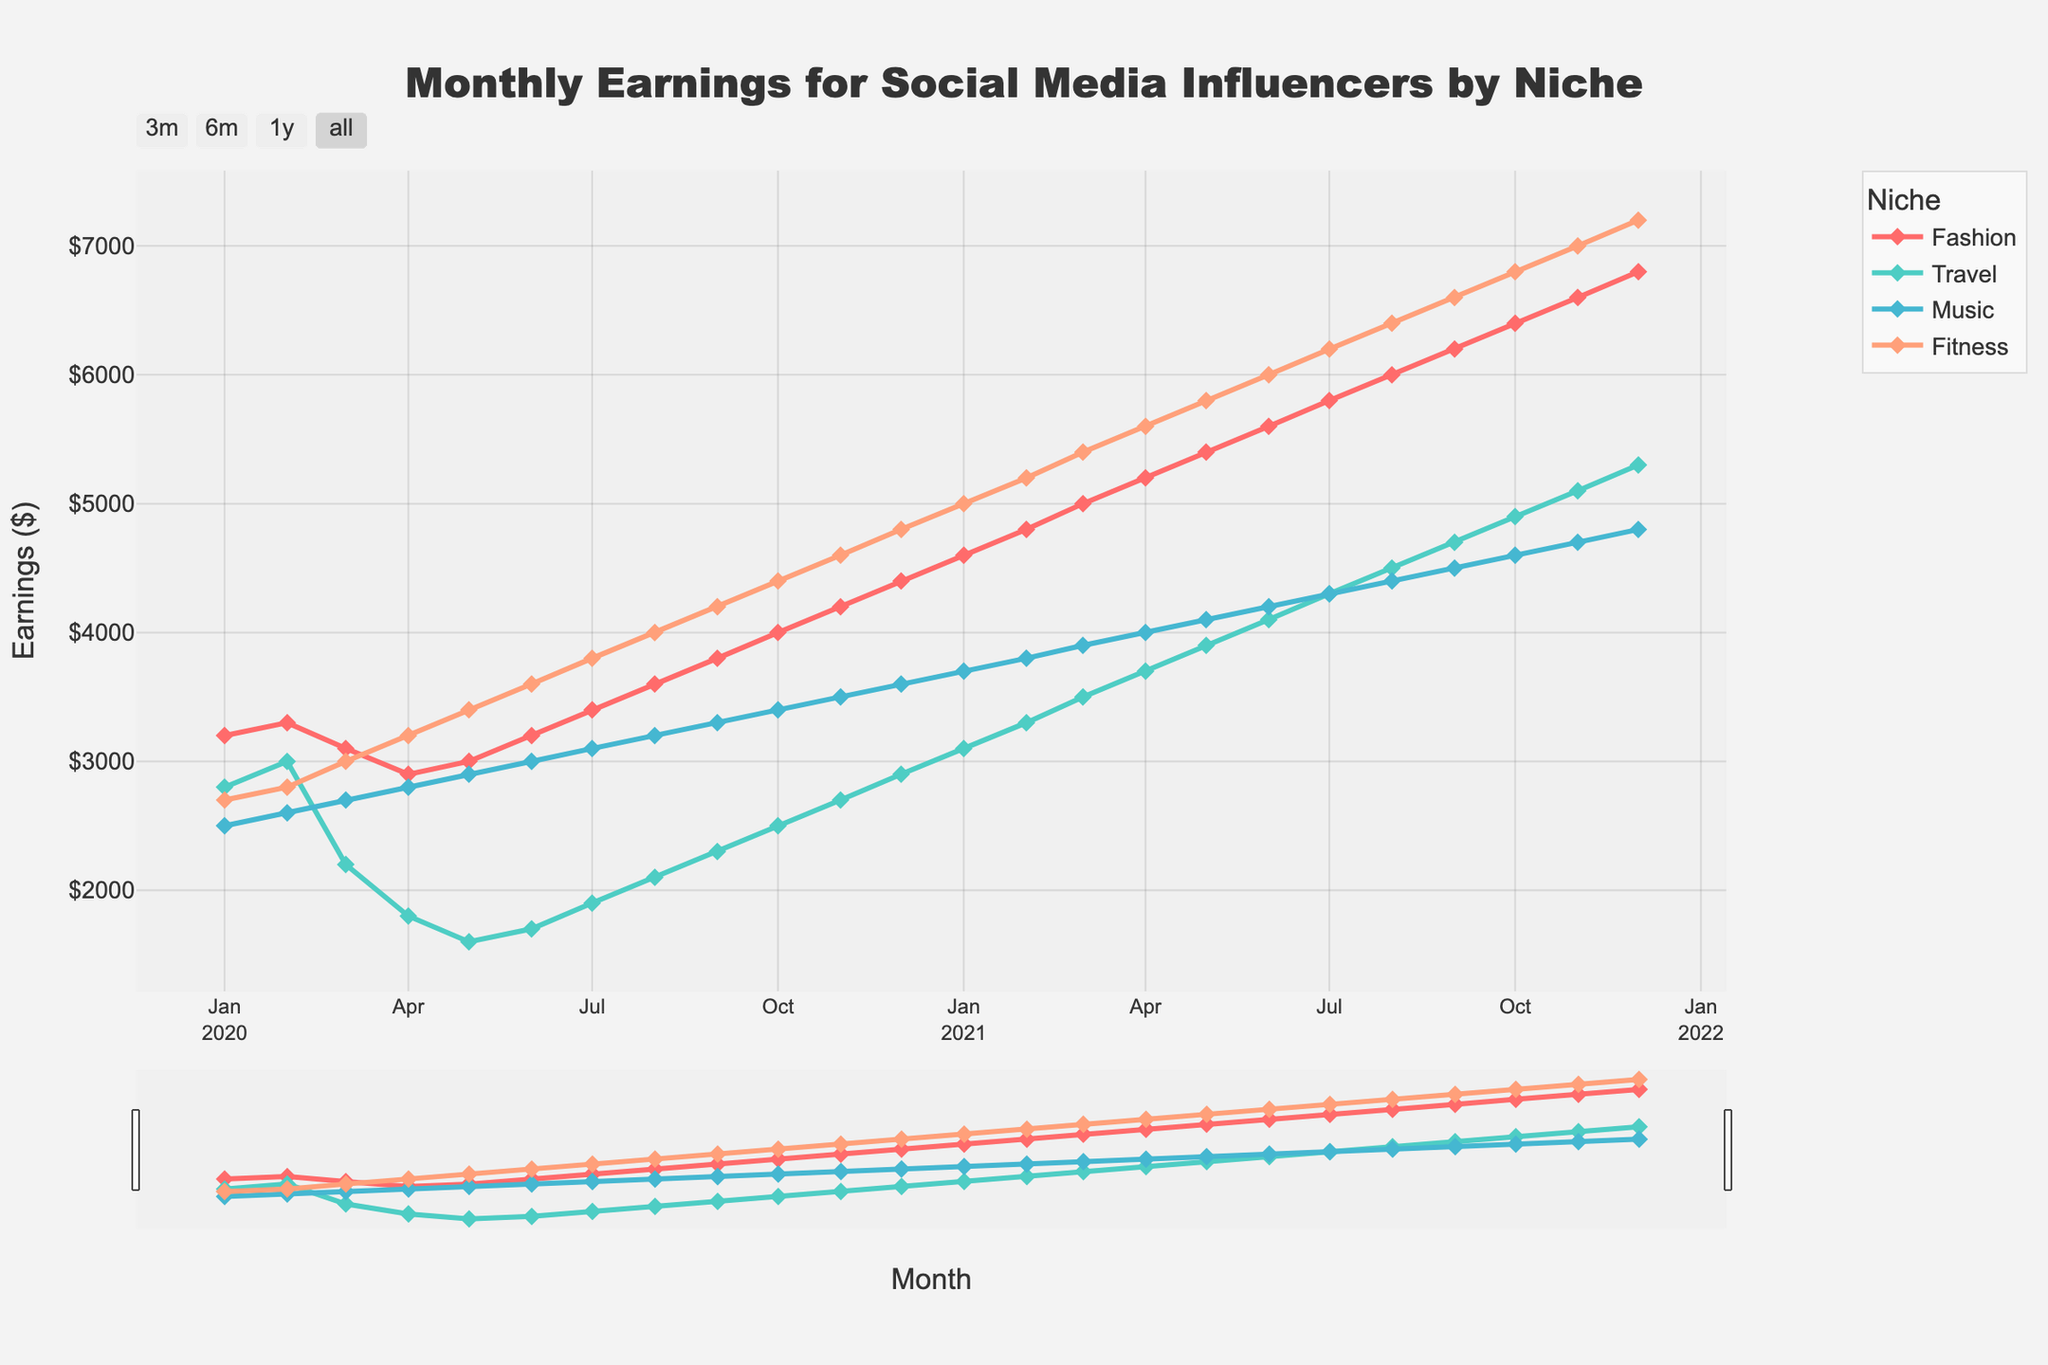What was the earnings difference between the Fitness and Travel niches in June 2021? In June 2021, the earnings for Fitness are $6000, and for Travel, it's $4100. The difference is $6000 - $4100 = $1900.
Answer: $1900 Which niche had the highest growth in earnings from January 2020 to December 2021? In January 2020, Fashion had $3200, Travel had $2800, Music had $2500, and Fitness had $2700. By December 2021, Fashion had $6800, Travel had $5300, Music had $4800, and Fitness had $7200. The growths are: Fashion $6800-$3200=$3600, Travel $5300-$2800=$2500, Music $4800-$2500=$2300, and Fitness $7200-$2700=$4500. Fitness has the highest growth of $4500.
Answer: Fitness During which month did Fashion's earnings surpass Fitness's for the first time? Reviewing the chart, we see that in every month listed, Fashion's earnings do not exceed Fitness's earnings. Thus, there is no month where Fashion's earnings surpass Fitness's earnings.
Answer: Never What is the average monthly earnings for the Music niche in 2020? The monthly earnings for Music in 2020 are $2500, $2600, $2700, $2800, $2900, $3000, $3100, $3200, $3300, $3400, $3500, and $3600. Adding these gives $36000. There are 12 months, so the average is $36000/12 = $3000.
Answer: $3000 Which niche showed the most stable earnings in 2020? Stability can be inferred from the smoothness of the line. Examining the graph, the Fashion line is the smoothest in 2020 with the least fluctuations compared to Travel, Music, and Fitness.
Answer: Fashion In April 2020, how much more did Fitness earn compared to Travel? In April 2020, Fitness earned $3200, and Travel earned $1800. The difference is $3200 - $1800 = $1400.
Answer: $1400 How does the earnings trend for Travel compare to Music from June 2020 to December 2021? The trend for Travel shows a gradual upward slope from June 2020 to December 2021, starting at $1700 and reaching $5300. Music, however, starts at $3000 in June 2020 and reaches $4800 by December 2021. Both trends are upward, but Travel had a lower starting point and significant growth.
Answer: Travel had greater relative growth but started lower Between February 2020 and February 2021, which niche experienced the least growth in earnings? From February 2020 to February 2021: Fashion went from $3300 to $4800 (growth $1500), Travel from $3000 to $3300 (growth $300), Music from $2600 to $3800 (growth $1200), and Fitness from $2800 to $5200 (growth $2400). Travel had the least growth of $300.
Answer: Travel 